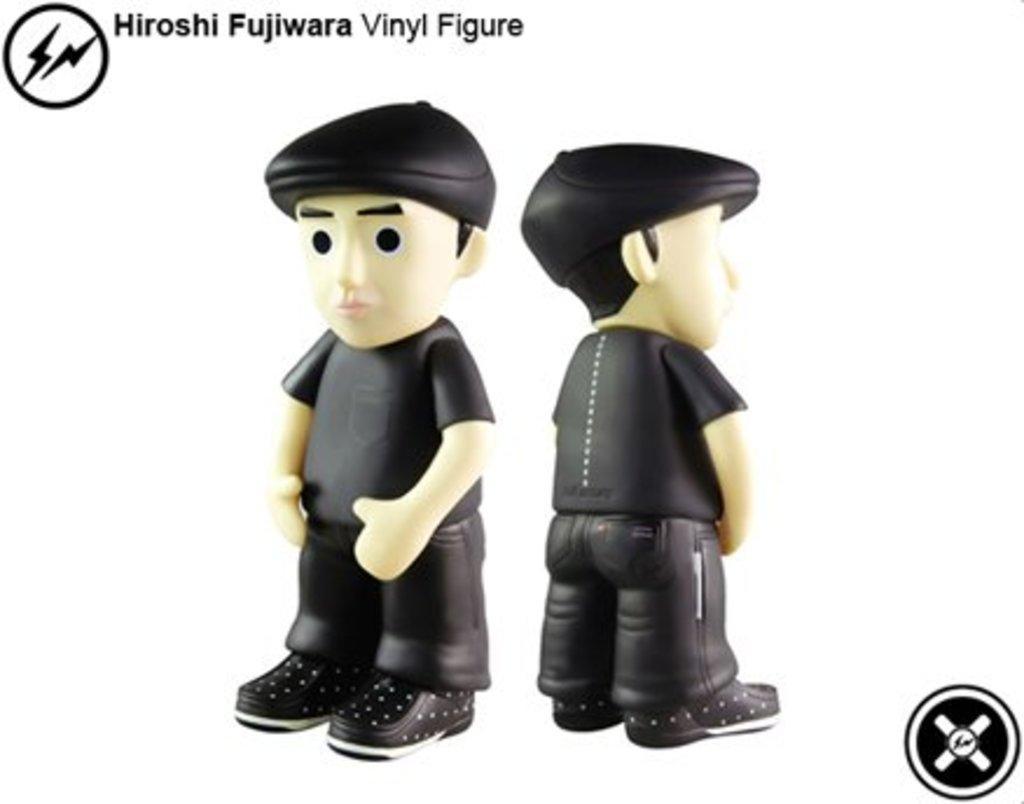How would you summarize this image in a sentence or two? In the center of this picture we can see the toys of persons wearing black color dresses, black color hats and standing and we can see the text and some pictures on the image. The background of the image is white in color. 